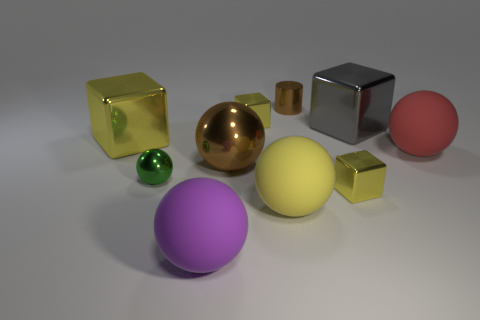Subtract all red cylinders. How many yellow blocks are left? 3 Subtract all purple balls. How many balls are left? 4 Subtract all red rubber balls. How many balls are left? 4 Subtract all gray balls. Subtract all purple cylinders. How many balls are left? 5 Subtract all cylinders. How many objects are left? 9 Subtract all big gray shiny things. Subtract all big brown metal things. How many objects are left? 8 Add 5 small yellow cubes. How many small yellow cubes are left? 7 Add 9 blue matte spheres. How many blue matte spheres exist? 9 Subtract 0 purple cubes. How many objects are left? 10 